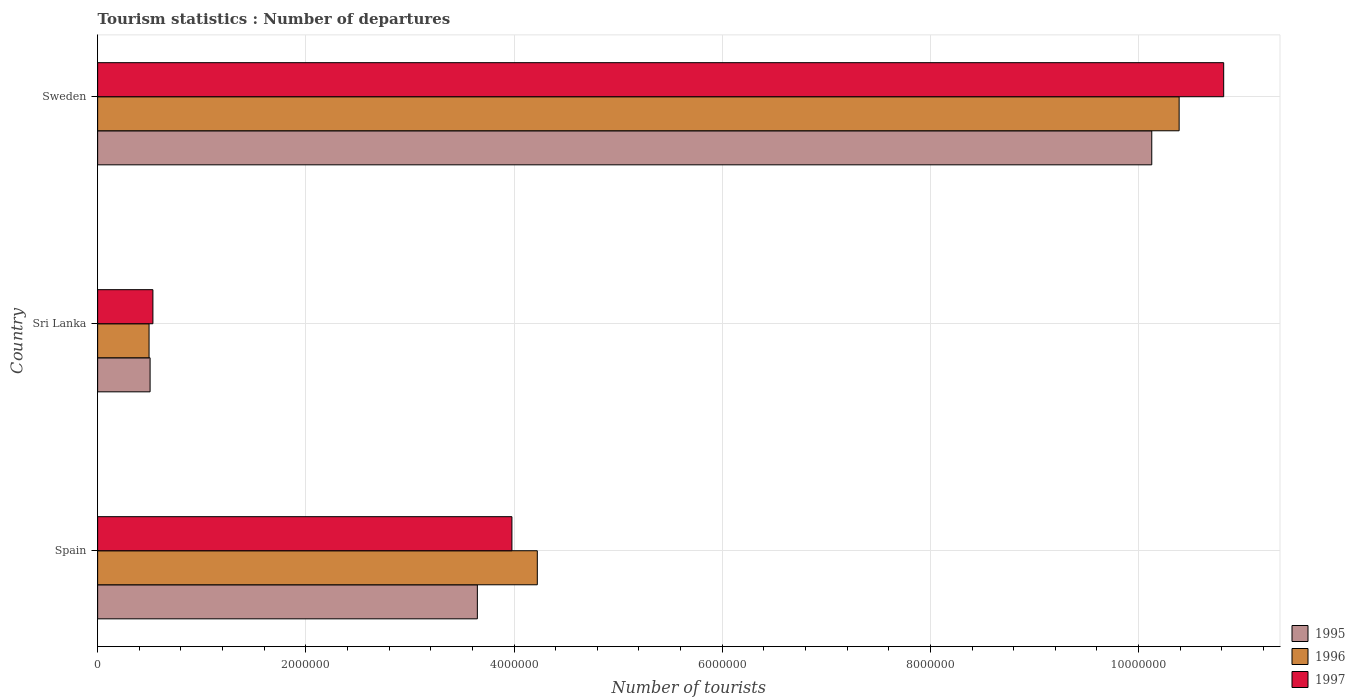How many bars are there on the 3rd tick from the bottom?
Make the answer very short. 3. What is the label of the 2nd group of bars from the top?
Provide a succinct answer. Sri Lanka. In how many cases, is the number of bars for a given country not equal to the number of legend labels?
Ensure brevity in your answer.  0. What is the number of tourist departures in 1997 in Sri Lanka?
Provide a succinct answer. 5.31e+05. Across all countries, what is the maximum number of tourist departures in 1996?
Offer a very short reply. 1.04e+07. Across all countries, what is the minimum number of tourist departures in 1995?
Your answer should be compact. 5.04e+05. In which country was the number of tourist departures in 1997 maximum?
Your answer should be compact. Sweden. In which country was the number of tourist departures in 1997 minimum?
Offer a very short reply. Sri Lanka. What is the total number of tourist departures in 1996 in the graph?
Your answer should be very brief. 1.51e+07. What is the difference between the number of tourist departures in 1995 in Spain and that in Sweden?
Make the answer very short. -6.48e+06. What is the difference between the number of tourist departures in 1995 in Sri Lanka and the number of tourist departures in 1997 in Spain?
Ensure brevity in your answer.  -3.48e+06. What is the average number of tourist departures in 1996 per country?
Provide a succinct answer. 5.04e+06. What is the difference between the number of tourist departures in 1997 and number of tourist departures in 1995 in Sweden?
Provide a short and direct response. 6.91e+05. What is the ratio of the number of tourist departures in 1995 in Sri Lanka to that in Sweden?
Your response must be concise. 0.05. Is the number of tourist departures in 1997 in Spain less than that in Sri Lanka?
Your response must be concise. No. What is the difference between the highest and the second highest number of tourist departures in 1996?
Your answer should be very brief. 6.17e+06. What is the difference between the highest and the lowest number of tourist departures in 1997?
Your answer should be very brief. 1.03e+07. In how many countries, is the number of tourist departures in 1995 greater than the average number of tourist departures in 1995 taken over all countries?
Keep it short and to the point. 1. Is the sum of the number of tourist departures in 1996 in Spain and Sri Lanka greater than the maximum number of tourist departures in 1997 across all countries?
Ensure brevity in your answer.  No. What does the 1st bar from the bottom in Sri Lanka represents?
Give a very brief answer. 1995. How many countries are there in the graph?
Your answer should be compact. 3. What is the difference between two consecutive major ticks on the X-axis?
Your answer should be compact. 2.00e+06. Are the values on the major ticks of X-axis written in scientific E-notation?
Provide a succinct answer. No. Does the graph contain any zero values?
Your response must be concise. No. Does the graph contain grids?
Keep it short and to the point. Yes. Where does the legend appear in the graph?
Offer a very short reply. Bottom right. How are the legend labels stacked?
Your answer should be compact. Vertical. What is the title of the graph?
Make the answer very short. Tourism statistics : Number of departures. What is the label or title of the X-axis?
Make the answer very short. Number of tourists. What is the label or title of the Y-axis?
Your response must be concise. Country. What is the Number of tourists of 1995 in Spain?
Offer a very short reply. 3.65e+06. What is the Number of tourists in 1996 in Spain?
Offer a terse response. 4.22e+06. What is the Number of tourists of 1997 in Spain?
Your answer should be very brief. 3.98e+06. What is the Number of tourists in 1995 in Sri Lanka?
Offer a very short reply. 5.04e+05. What is the Number of tourists of 1996 in Sri Lanka?
Provide a short and direct response. 4.94e+05. What is the Number of tourists of 1997 in Sri Lanka?
Offer a very short reply. 5.31e+05. What is the Number of tourists in 1995 in Sweden?
Provide a short and direct response. 1.01e+07. What is the Number of tourists of 1996 in Sweden?
Your response must be concise. 1.04e+07. What is the Number of tourists of 1997 in Sweden?
Your response must be concise. 1.08e+07. Across all countries, what is the maximum Number of tourists of 1995?
Give a very brief answer. 1.01e+07. Across all countries, what is the maximum Number of tourists in 1996?
Ensure brevity in your answer.  1.04e+07. Across all countries, what is the maximum Number of tourists in 1997?
Provide a succinct answer. 1.08e+07. Across all countries, what is the minimum Number of tourists in 1995?
Ensure brevity in your answer.  5.04e+05. Across all countries, what is the minimum Number of tourists in 1996?
Your answer should be very brief. 4.94e+05. Across all countries, what is the minimum Number of tourists in 1997?
Your answer should be compact. 5.31e+05. What is the total Number of tourists in 1995 in the graph?
Provide a short and direct response. 1.43e+07. What is the total Number of tourists in 1996 in the graph?
Your answer should be compact. 1.51e+07. What is the total Number of tourists of 1997 in the graph?
Your answer should be very brief. 1.53e+07. What is the difference between the Number of tourists of 1995 in Spain and that in Sri Lanka?
Make the answer very short. 3.14e+06. What is the difference between the Number of tourists in 1996 in Spain and that in Sri Lanka?
Your answer should be compact. 3.73e+06. What is the difference between the Number of tourists of 1997 in Spain and that in Sri Lanka?
Make the answer very short. 3.45e+06. What is the difference between the Number of tourists in 1995 in Spain and that in Sweden?
Your answer should be compact. -6.48e+06. What is the difference between the Number of tourists in 1996 in Spain and that in Sweden?
Provide a short and direct response. -6.17e+06. What is the difference between the Number of tourists in 1997 in Spain and that in Sweden?
Make the answer very short. -6.84e+06. What is the difference between the Number of tourists in 1995 in Sri Lanka and that in Sweden?
Provide a short and direct response. -9.62e+06. What is the difference between the Number of tourists in 1996 in Sri Lanka and that in Sweden?
Make the answer very short. -9.90e+06. What is the difference between the Number of tourists of 1997 in Sri Lanka and that in Sweden?
Keep it short and to the point. -1.03e+07. What is the difference between the Number of tourists in 1995 in Spain and the Number of tourists in 1996 in Sri Lanka?
Ensure brevity in your answer.  3.15e+06. What is the difference between the Number of tourists of 1995 in Spain and the Number of tourists of 1997 in Sri Lanka?
Provide a short and direct response. 3.12e+06. What is the difference between the Number of tourists of 1996 in Spain and the Number of tourists of 1997 in Sri Lanka?
Ensure brevity in your answer.  3.69e+06. What is the difference between the Number of tourists in 1995 in Spain and the Number of tourists in 1996 in Sweden?
Ensure brevity in your answer.  -6.74e+06. What is the difference between the Number of tourists of 1995 in Spain and the Number of tourists of 1997 in Sweden?
Your answer should be very brief. -7.17e+06. What is the difference between the Number of tourists in 1996 in Spain and the Number of tourists in 1997 in Sweden?
Make the answer very short. -6.59e+06. What is the difference between the Number of tourists of 1995 in Sri Lanka and the Number of tourists of 1996 in Sweden?
Offer a terse response. -9.89e+06. What is the difference between the Number of tourists of 1995 in Sri Lanka and the Number of tourists of 1997 in Sweden?
Make the answer very short. -1.03e+07. What is the difference between the Number of tourists of 1996 in Sri Lanka and the Number of tourists of 1997 in Sweden?
Your response must be concise. -1.03e+07. What is the average Number of tourists in 1995 per country?
Offer a terse response. 4.76e+06. What is the average Number of tourists of 1996 per country?
Offer a very short reply. 5.04e+06. What is the average Number of tourists in 1997 per country?
Give a very brief answer. 5.11e+06. What is the difference between the Number of tourists in 1995 and Number of tourists in 1996 in Spain?
Offer a terse response. -5.76e+05. What is the difference between the Number of tourists of 1995 and Number of tourists of 1997 in Spain?
Make the answer very short. -3.32e+05. What is the difference between the Number of tourists of 1996 and Number of tourists of 1997 in Spain?
Offer a very short reply. 2.44e+05. What is the difference between the Number of tourists in 1995 and Number of tourists in 1996 in Sri Lanka?
Your response must be concise. 10000. What is the difference between the Number of tourists in 1995 and Number of tourists in 1997 in Sri Lanka?
Provide a succinct answer. -2.70e+04. What is the difference between the Number of tourists in 1996 and Number of tourists in 1997 in Sri Lanka?
Your answer should be very brief. -3.70e+04. What is the difference between the Number of tourists in 1995 and Number of tourists in 1996 in Sweden?
Provide a succinct answer. -2.63e+05. What is the difference between the Number of tourists in 1995 and Number of tourists in 1997 in Sweden?
Make the answer very short. -6.91e+05. What is the difference between the Number of tourists of 1996 and Number of tourists of 1997 in Sweden?
Provide a succinct answer. -4.28e+05. What is the ratio of the Number of tourists in 1995 in Spain to that in Sri Lanka?
Give a very brief answer. 7.24. What is the ratio of the Number of tourists of 1996 in Spain to that in Sri Lanka?
Your answer should be very brief. 8.55. What is the ratio of the Number of tourists of 1997 in Spain to that in Sri Lanka?
Offer a terse response. 7.5. What is the ratio of the Number of tourists in 1995 in Spain to that in Sweden?
Make the answer very short. 0.36. What is the ratio of the Number of tourists in 1996 in Spain to that in Sweden?
Your response must be concise. 0.41. What is the ratio of the Number of tourists in 1997 in Spain to that in Sweden?
Offer a terse response. 0.37. What is the ratio of the Number of tourists in 1995 in Sri Lanka to that in Sweden?
Offer a terse response. 0.05. What is the ratio of the Number of tourists of 1996 in Sri Lanka to that in Sweden?
Keep it short and to the point. 0.05. What is the ratio of the Number of tourists in 1997 in Sri Lanka to that in Sweden?
Give a very brief answer. 0.05. What is the difference between the highest and the second highest Number of tourists in 1995?
Your answer should be compact. 6.48e+06. What is the difference between the highest and the second highest Number of tourists in 1996?
Give a very brief answer. 6.17e+06. What is the difference between the highest and the second highest Number of tourists of 1997?
Ensure brevity in your answer.  6.84e+06. What is the difference between the highest and the lowest Number of tourists in 1995?
Offer a terse response. 9.62e+06. What is the difference between the highest and the lowest Number of tourists of 1996?
Offer a terse response. 9.90e+06. What is the difference between the highest and the lowest Number of tourists in 1997?
Offer a terse response. 1.03e+07. 